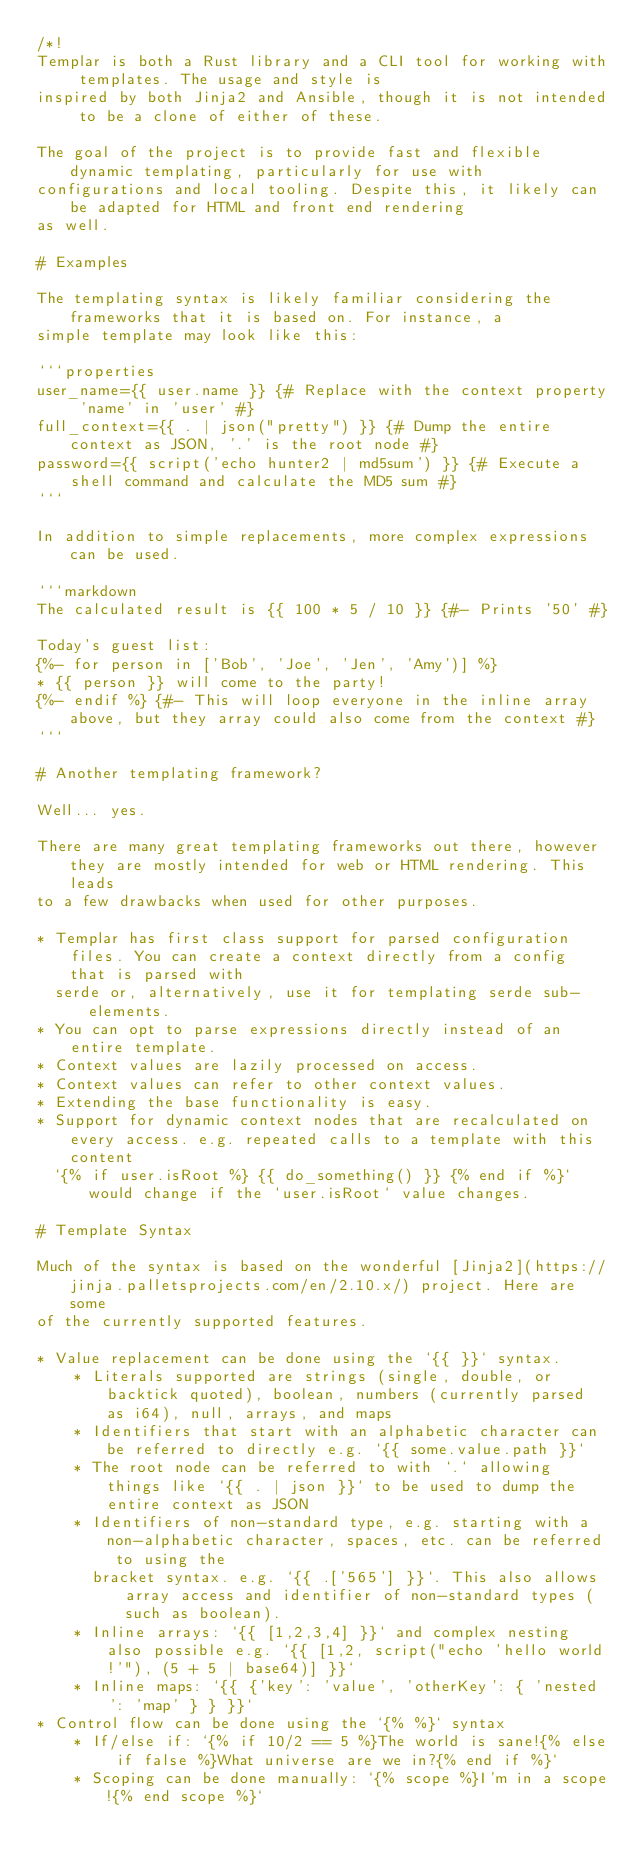<code> <loc_0><loc_0><loc_500><loc_500><_Rust_>/*!
Templar is both a Rust library and a CLI tool for working with templates. The usage and style is
inspired by both Jinja2 and Ansible, though it is not intended to be a clone of either of these.

The goal of the project is to provide fast and flexible dynamic templating, particularly for use with
configurations and local tooling. Despite this, it likely can be adapted for HTML and front end rendering
as well.

# Examples

The templating syntax is likely familiar considering the frameworks that it is based on. For instance, a
simple template may look like this:

```properties
user_name={{ user.name }} {# Replace with the context property 'name' in 'user' #}
full_context={{ . | json("pretty") }} {# Dump the entire context as JSON, '.' is the root node #}
password={{ script('echo hunter2 | md5sum') }} {# Execute a shell command and calculate the MD5 sum #}
```

In addition to simple replacements, more complex expressions can be used.

```markdown
The calculated result is {{ 100 * 5 / 10 }} {#- Prints '50' #}

Today's guest list:
{%- for person in ['Bob', 'Joe', 'Jen', 'Amy')] %}
* {{ person }} will come to the party!
{%- endif %} {#- This will loop everyone in the inline array above, but they array could also come from the context #}
```

# Another templating framework?

Well... yes.

There are many great templating frameworks out there, however they are mostly intended for web or HTML rendering. This leads
to a few drawbacks when used for other purposes.

* Templar has first class support for parsed configuration files. You can create a context directly from a config that is parsed with
  serde or, alternatively, use it for templating serde sub-elements.
* You can opt to parse expressions directly instead of an entire template.
* Context values are lazily processed on access.
* Context values can refer to other context values.
* Extending the base functionality is easy.
* Support for dynamic context nodes that are recalculated on every access. e.g. repeated calls to a template with this content
  `{% if user.isRoot %} {{ do_something() }} {% end if %}` would change if the `user.isRoot` value changes.

# Template Syntax

Much of the syntax is based on the wonderful [Jinja2](https://jinja.palletsprojects.com/en/2.10.x/) project. Here are some
of the currently supported features.

* Value replacement can be done using the `{{ }}` syntax.
    * Literals supported are strings (single, double, or backtick quoted), boolean, numbers (currently parsed as i64), null, arrays, and maps
    * Identifiers that start with an alphabetic character can be referred to directly e.g. `{{ some.value.path }}`
    * The root node can be referred to with `.` allowing things like `{{ . | json }}` to be used to dump the entire context as JSON
    * Identifiers of non-standard type, e.g. starting with a non-alphabetic character, spaces, etc. can be referred to using the
      bracket syntax. e.g. `{{ .['565'] }}`. This also allows array access and identifier of non-standard types (such as boolean).
    * Inline arrays: `{{ [1,2,3,4] }}` and complex nesting also possible e.g. `{{ [1,2, script("echo 'hello world!'"), (5 + 5 | base64)] }}`
    * Inline maps: `{{ {'key': 'value', 'otherKey': { 'nested': 'map' } } }}`
* Control flow can be done using the `{% %}` syntax
    * If/else if: `{% if 10/2 == 5 %}The world is sane!{% else if false %}What universe are we in?{% end if %}`
    * Scoping can be done manually: `{% scope %}I'm in a scope!{% end scope %}`</code> 